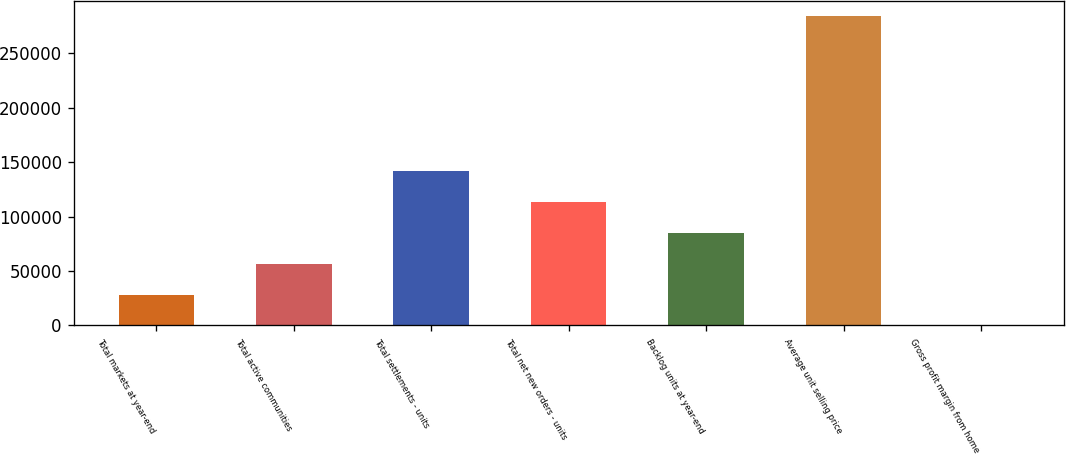<chart> <loc_0><loc_0><loc_500><loc_500><bar_chart><fcel>Total markets at year-end<fcel>Total active communities<fcel>Total settlements - units<fcel>Total net new orders - units<fcel>Backlog units at year-end<fcel>Average unit selling price<fcel>Gross profit margin from home<nl><fcel>28409.1<fcel>56808.1<fcel>142005<fcel>113606<fcel>85207.1<fcel>284000<fcel>10.1<nl></chart> 